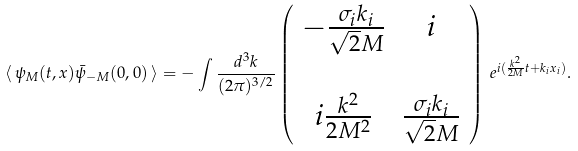<formula> <loc_0><loc_0><loc_500><loc_500>\langle \, \psi _ { M } ( t , x ) \bar { \psi } _ { - M } ( 0 , 0 ) \, \rangle = - \int \frac { d ^ { 3 } k } { ( 2 \pi ) ^ { 3 / 2 } } \left ( \begin{array} { c c } - \frac { \sigma _ { i } k _ { i } } { \sqrt { 2 } M } & i \\ & \\ i \frac { k ^ { 2 } } { 2 M ^ { 2 } } & \frac { \sigma _ { i } k _ { i } } { \sqrt { 2 } M } \end{array} \right ) \, e ^ { i ( \frac { k ^ { 2 } } { 2 M } t + k _ { i } x _ { i } ) } .</formula> 